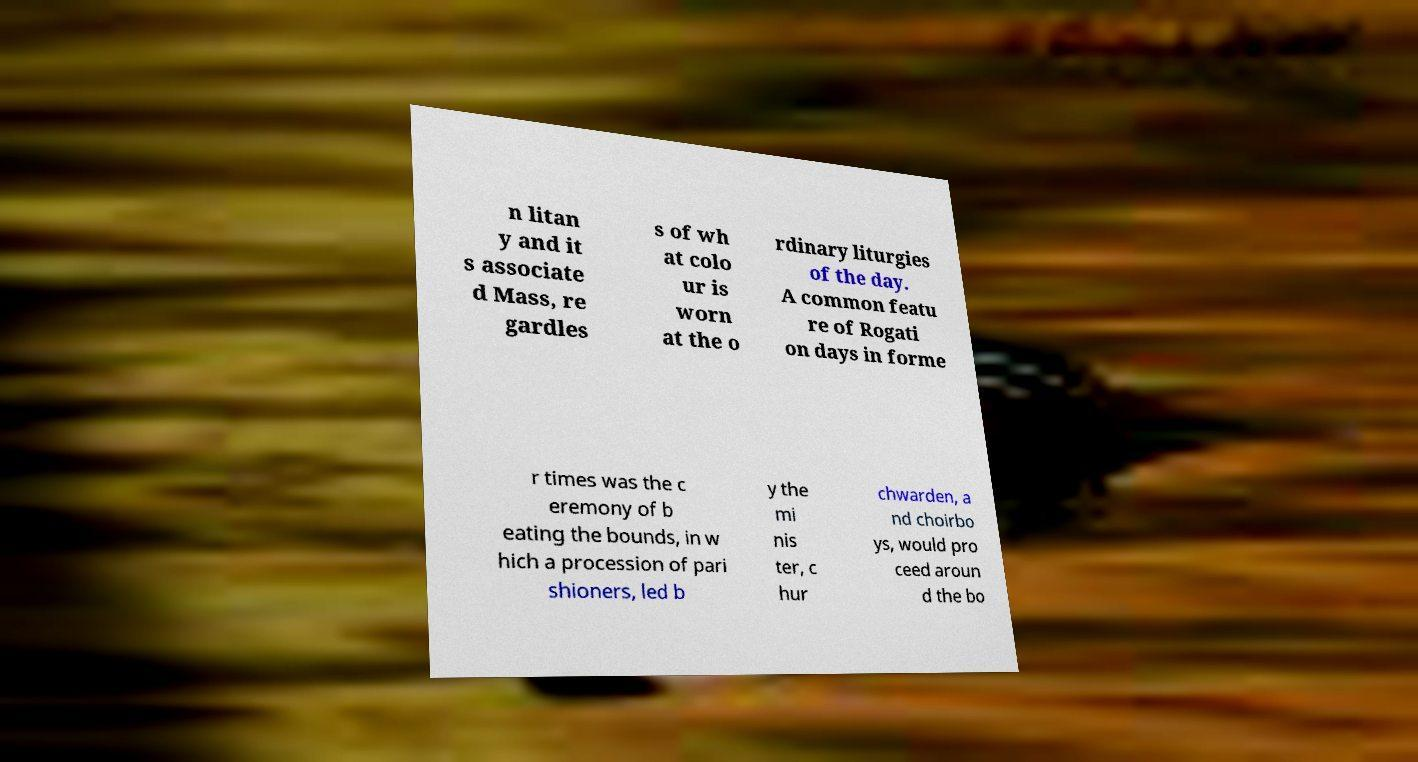I need the written content from this picture converted into text. Can you do that? n litan y and it s associate d Mass, re gardles s of wh at colo ur is worn at the o rdinary liturgies of the day. A common featu re of Rogati on days in forme r times was the c eremony of b eating the bounds, in w hich a procession of pari shioners, led b y the mi nis ter, c hur chwarden, a nd choirbo ys, would pro ceed aroun d the bo 